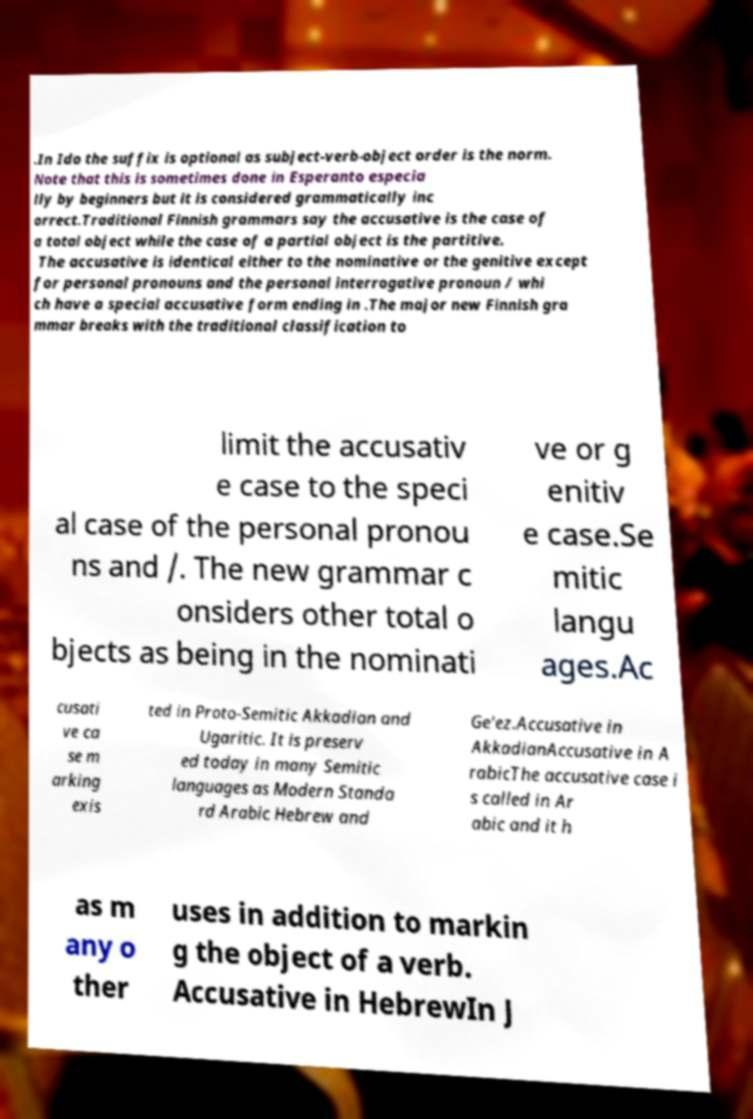For documentation purposes, I need the text within this image transcribed. Could you provide that? .In Ido the suffix is optional as subject-verb-object order is the norm. Note that this is sometimes done in Esperanto especia lly by beginners but it is considered grammatically inc orrect.Traditional Finnish grammars say the accusative is the case of a total object while the case of a partial object is the partitive. The accusative is identical either to the nominative or the genitive except for personal pronouns and the personal interrogative pronoun / whi ch have a special accusative form ending in .The major new Finnish gra mmar breaks with the traditional classification to limit the accusativ e case to the speci al case of the personal pronou ns and /. The new grammar c onsiders other total o bjects as being in the nominati ve or g enitiv e case.Se mitic langu ages.Ac cusati ve ca se m arking exis ted in Proto-Semitic Akkadian and Ugaritic. It is preserv ed today in many Semitic languages as Modern Standa rd Arabic Hebrew and Ge'ez.Accusative in AkkadianAccusative in A rabicThe accusative case i s called in Ar abic and it h as m any o ther uses in addition to markin g the object of a verb. Accusative in HebrewIn J 